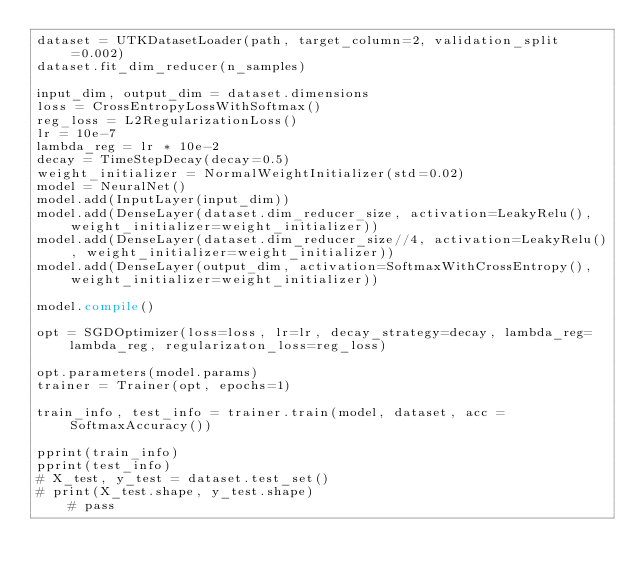Convert code to text. <code><loc_0><loc_0><loc_500><loc_500><_Python_>dataset = UTKDatasetLoader(path, target_column=2, validation_split=0.002)
dataset.fit_dim_reducer(n_samples)

input_dim, output_dim = dataset.dimensions
loss = CrossEntropyLossWithSoftmax()
reg_loss = L2RegularizationLoss()
lr = 10e-7
lambda_reg = lr * 10e-2
decay = TimeStepDecay(decay=0.5)
weight_initializer = NormalWeightInitializer(std=0.02)
model = NeuralNet()
model.add(InputLayer(input_dim))
model.add(DenseLayer(dataset.dim_reducer_size, activation=LeakyRelu(), weight_initializer=weight_initializer))
model.add(DenseLayer(dataset.dim_reducer_size//4, activation=LeakyRelu(), weight_initializer=weight_initializer))
model.add(DenseLayer(output_dim, activation=SoftmaxWithCrossEntropy(), weight_initializer=weight_initializer))

model.compile()

opt = SGDOptimizer(loss=loss, lr=lr, decay_strategy=decay, lambda_reg=lambda_reg, regularizaton_loss=reg_loss)

opt.parameters(model.params)
trainer = Trainer(opt, epochs=1)

train_info, test_info = trainer.train(model, dataset, acc = SoftmaxAccuracy())

pprint(train_info)
pprint(test_info)
# X_test, y_test = dataset.test_set()
# print(X_test.shape, y_test.shape)
    # pass</code> 